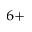<formula> <loc_0><loc_0><loc_500><loc_500>^ { 6 + }</formula> 